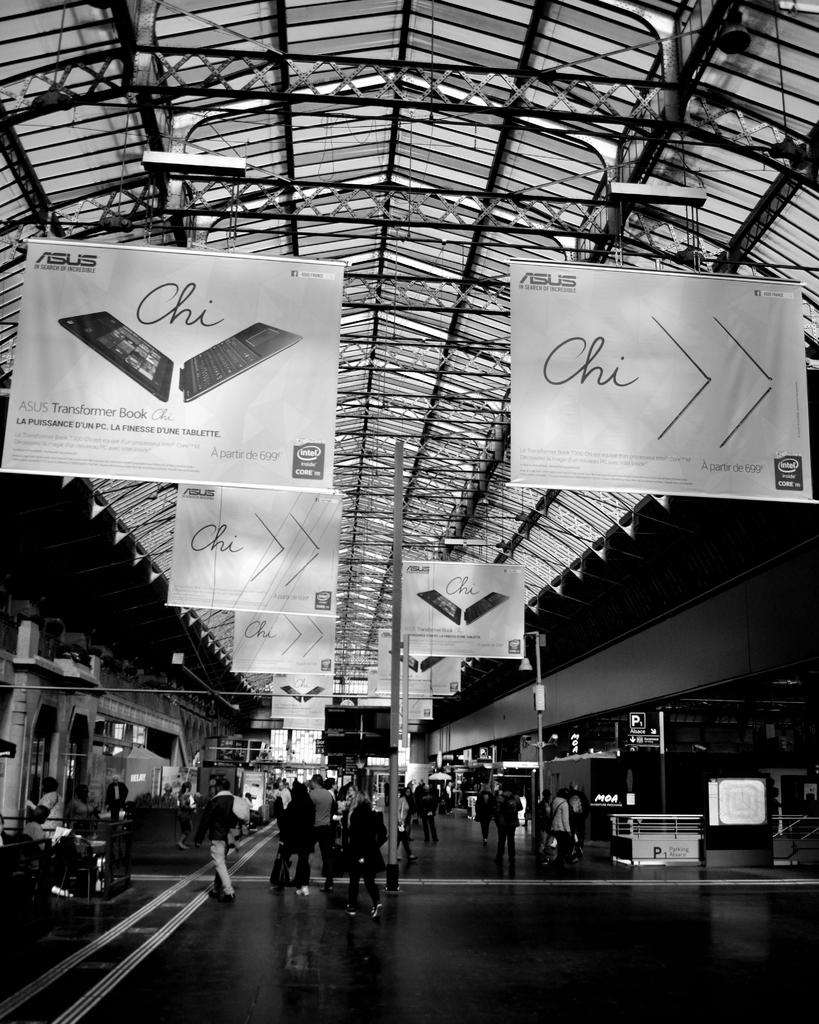What are the persons in the image doing? The persons in the image are walking. What can be seen beneath the persons in the image? The floor is visible in the image. What is located at the top of the image? There are boards, lights, and a roof visible at the top of the image. Can you see a toothbrush being used by any of the persons in the image? There is no toothbrush present in the image. Which eye of the person on the left side of the image is visible? There is no person on the left side of the image, and even if there were, the image does not provide enough detail to determine which eye is visible. 